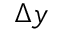<formula> <loc_0><loc_0><loc_500><loc_500>\Delta y</formula> 